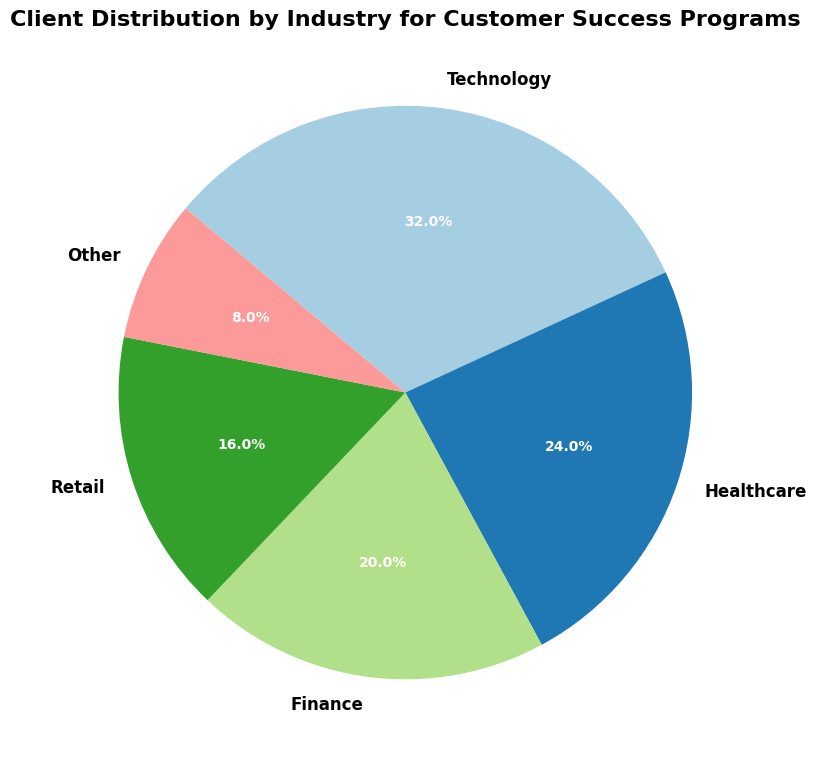What's the largest industry sector by client count in the pie chart? The largest sector can be identified by looking for the slice with the highest percentage. The Technology sector has the largest slice representing 120 clients, which is the highest count among all sectors.
Answer: Technology What's the combined percentage of clients in the Technology and Healthcare sectors? Add the percentage of clients from both the Technology and Healthcare sectors. Technology has 120 clients and Healthcare has 90 clients. The total number of clients is 375, so the combined percentage is ((120 + 90) / 375) * 100 = 56%.
Answer: 56% Compare the client counts of the Finance and Retail sectors. Which sector has fewer clients and by how many? Finance has 75 clients, and Retail has 60 clients. Subtract the Retail count from the Finance count to find the difference: 75 - 60 = 15. Retail has fewer clients by 15.
Answer: Retail, 15 How does the client count of the 'Other' sector compare to the average client count across all sectors? First, calculate the average client count by dividing the total number of clients (375) by the number of sectors (5): 375 / 5 = 75. The 'Other' sector has 30 clients, which is less than the average client count.
Answer: The 'Other' sector has fewer clients by 45 What is the visual difference between the Healthcare and Retail sectors in terms of their pie chart slices? The Healthcare sector has a significantly larger size compared to the Retail sector. This is evident by the larger wedge in the pie chart which represents more clients and a larger percentage of the total.
Answer: Healthcare has a larger slice 